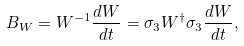<formula> <loc_0><loc_0><loc_500><loc_500>B _ { W } = W ^ { - 1 } \frac { d W } { d t } = \sigma _ { 3 } W ^ { \dag } \sigma _ { 3 } \frac { d W } { d t } ,</formula> 